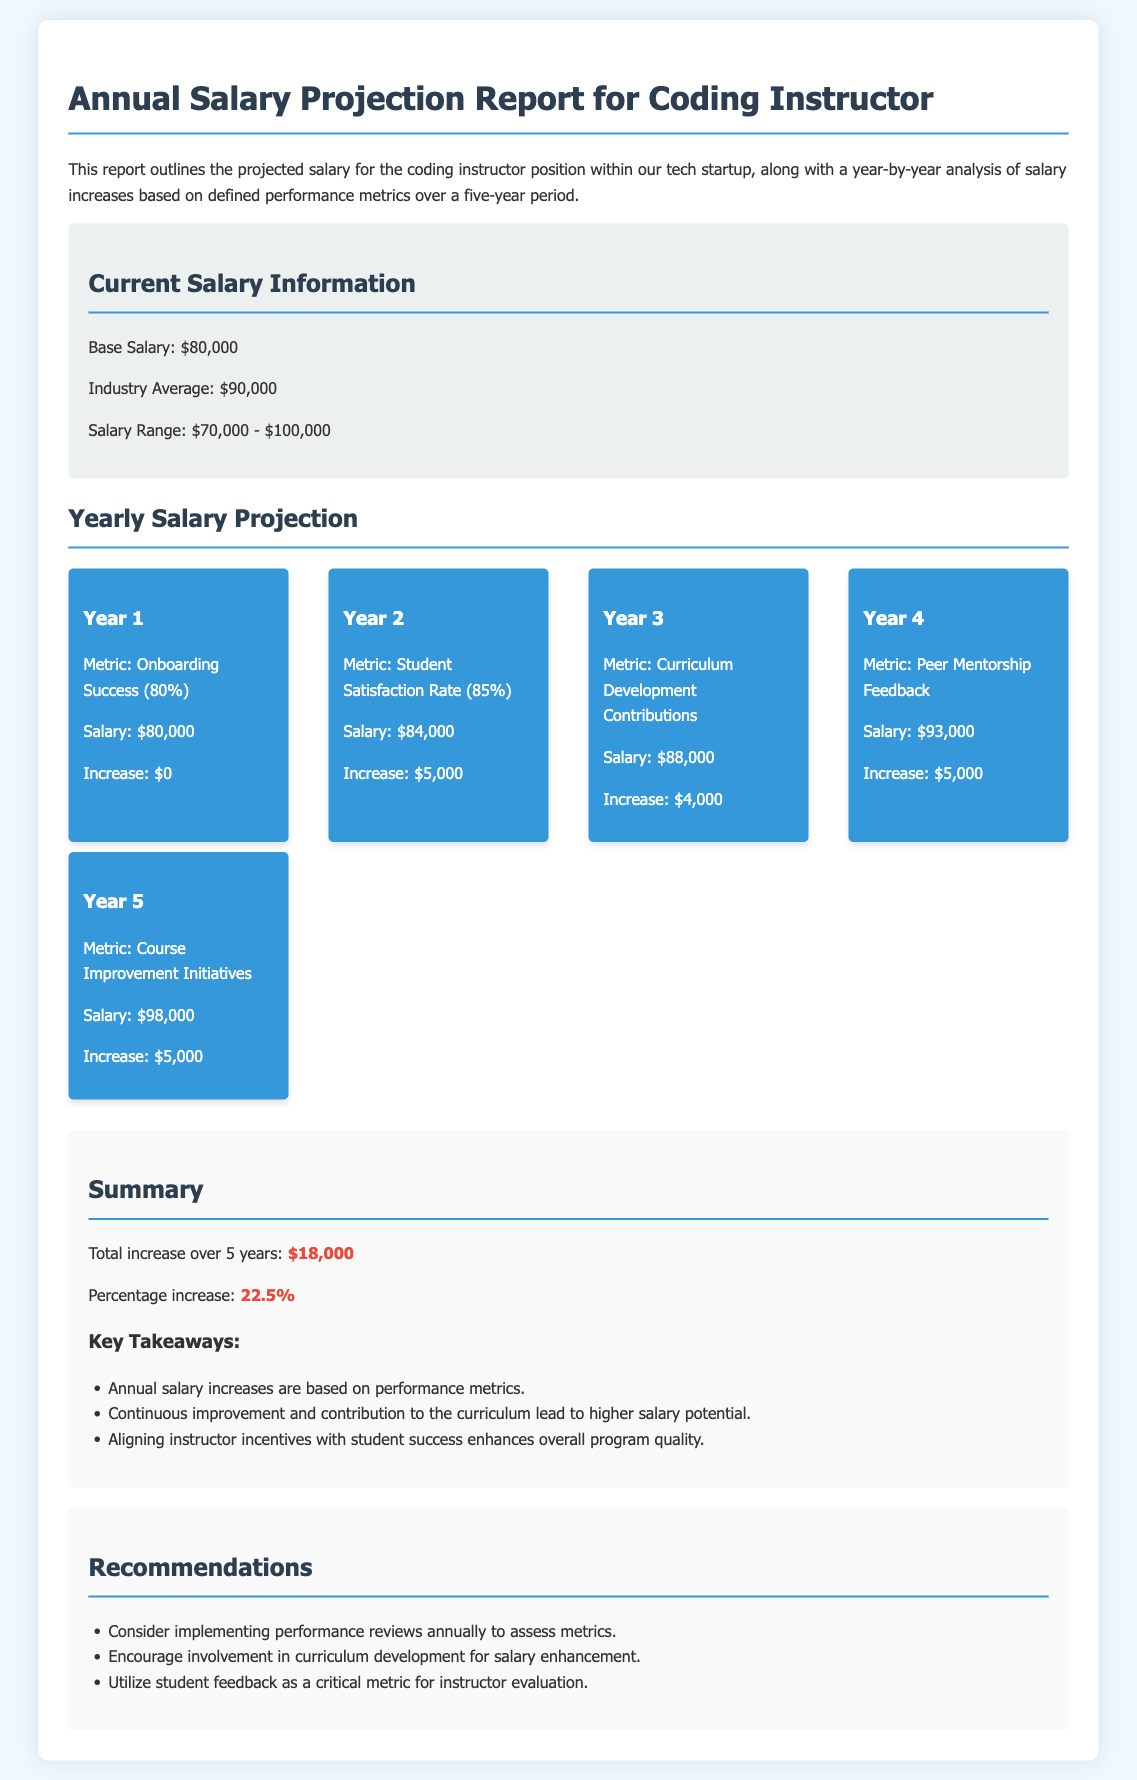What is the base salary for the coding instructor position? The base salary is stated in the document under current salary information.
Answer: $80,000 What is the industry average salary for a coding instructor? The industry average is mentioned in the current salary section of the report.
Answer: $90,000 What is the salary projection for Year 3? This information can be found in the yearly salary projections section of the document.
Answer: $88,000 How much is the total increase over 5 years? The document summarizes the total salary increase in the summary section.
Answer: $18,000 What metric is used to evaluate performance in Year 2? The specific metric for Year 2 is listed in the yearly salary projections.
Answer: Student Satisfaction Rate What percentage increase does the report indicate? This percentage is noted in the summary section of the report.
Answer: 22.5% What recommendation is given regarding curriculum development? This recommendation is mentioned in the recommendations section.
Answer: Encourage involvement in curriculum development for salary enhancement How much did the salary increase from Year 1 to Year 5? The difference between salaries in Year 1 and Year 5 reflects this increase.
Answer: $18,000 What is the salary for Year 4? The salary information for Year 4 can be found in the salary projections.
Answer: $93,000 